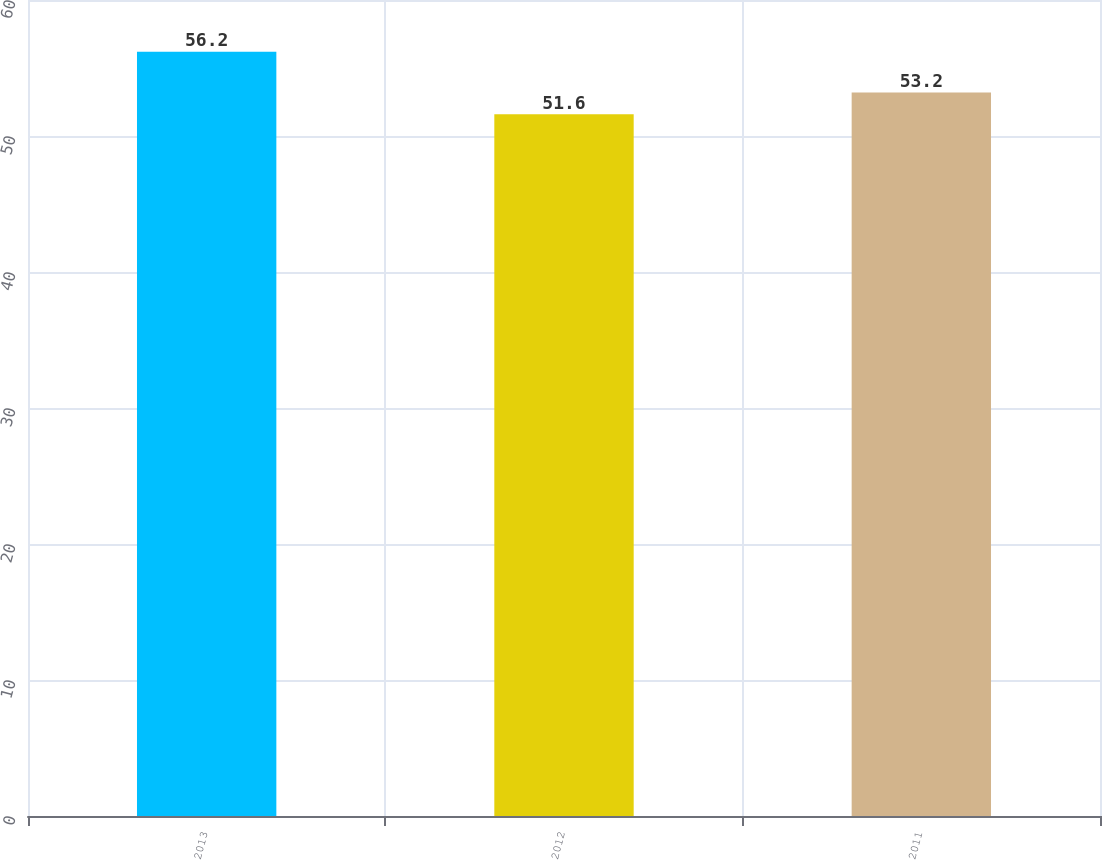Convert chart. <chart><loc_0><loc_0><loc_500><loc_500><bar_chart><fcel>2013<fcel>2012<fcel>2011<nl><fcel>56.2<fcel>51.6<fcel>53.2<nl></chart> 